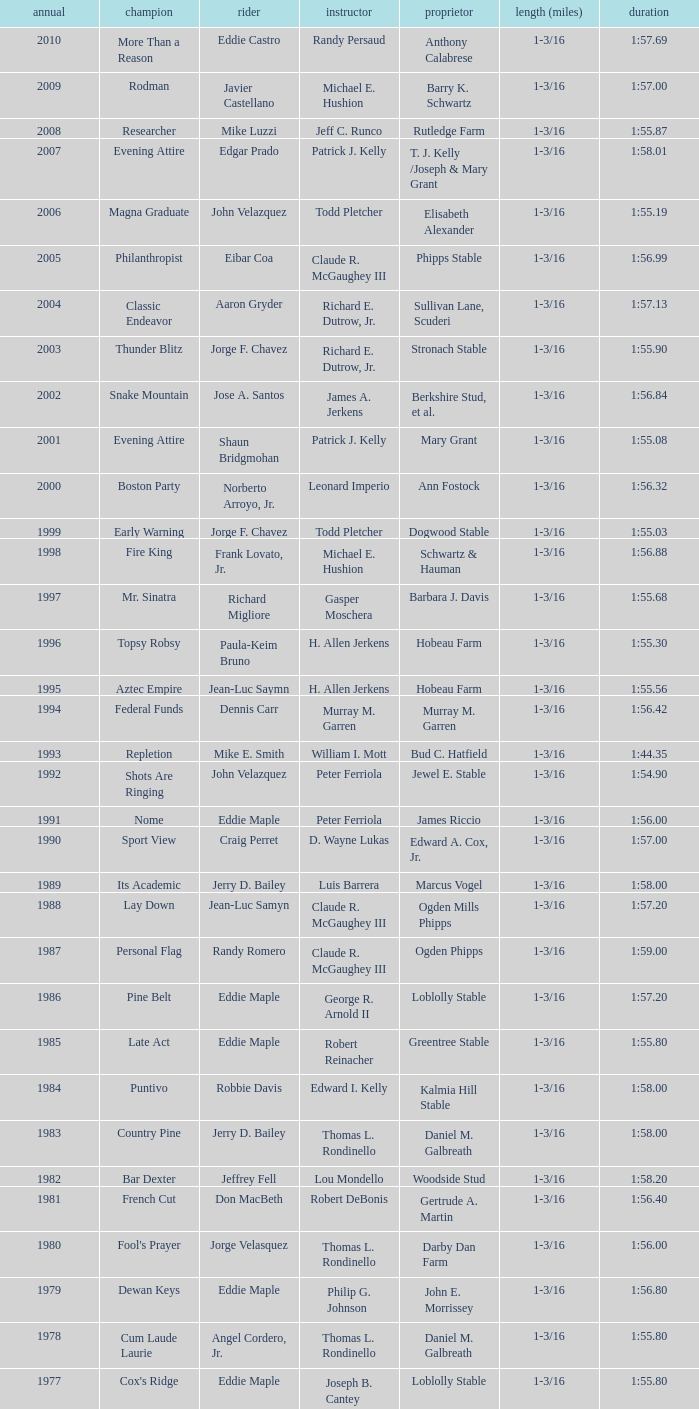What was the time for the winning horse Salford ii? 1:44.20. 